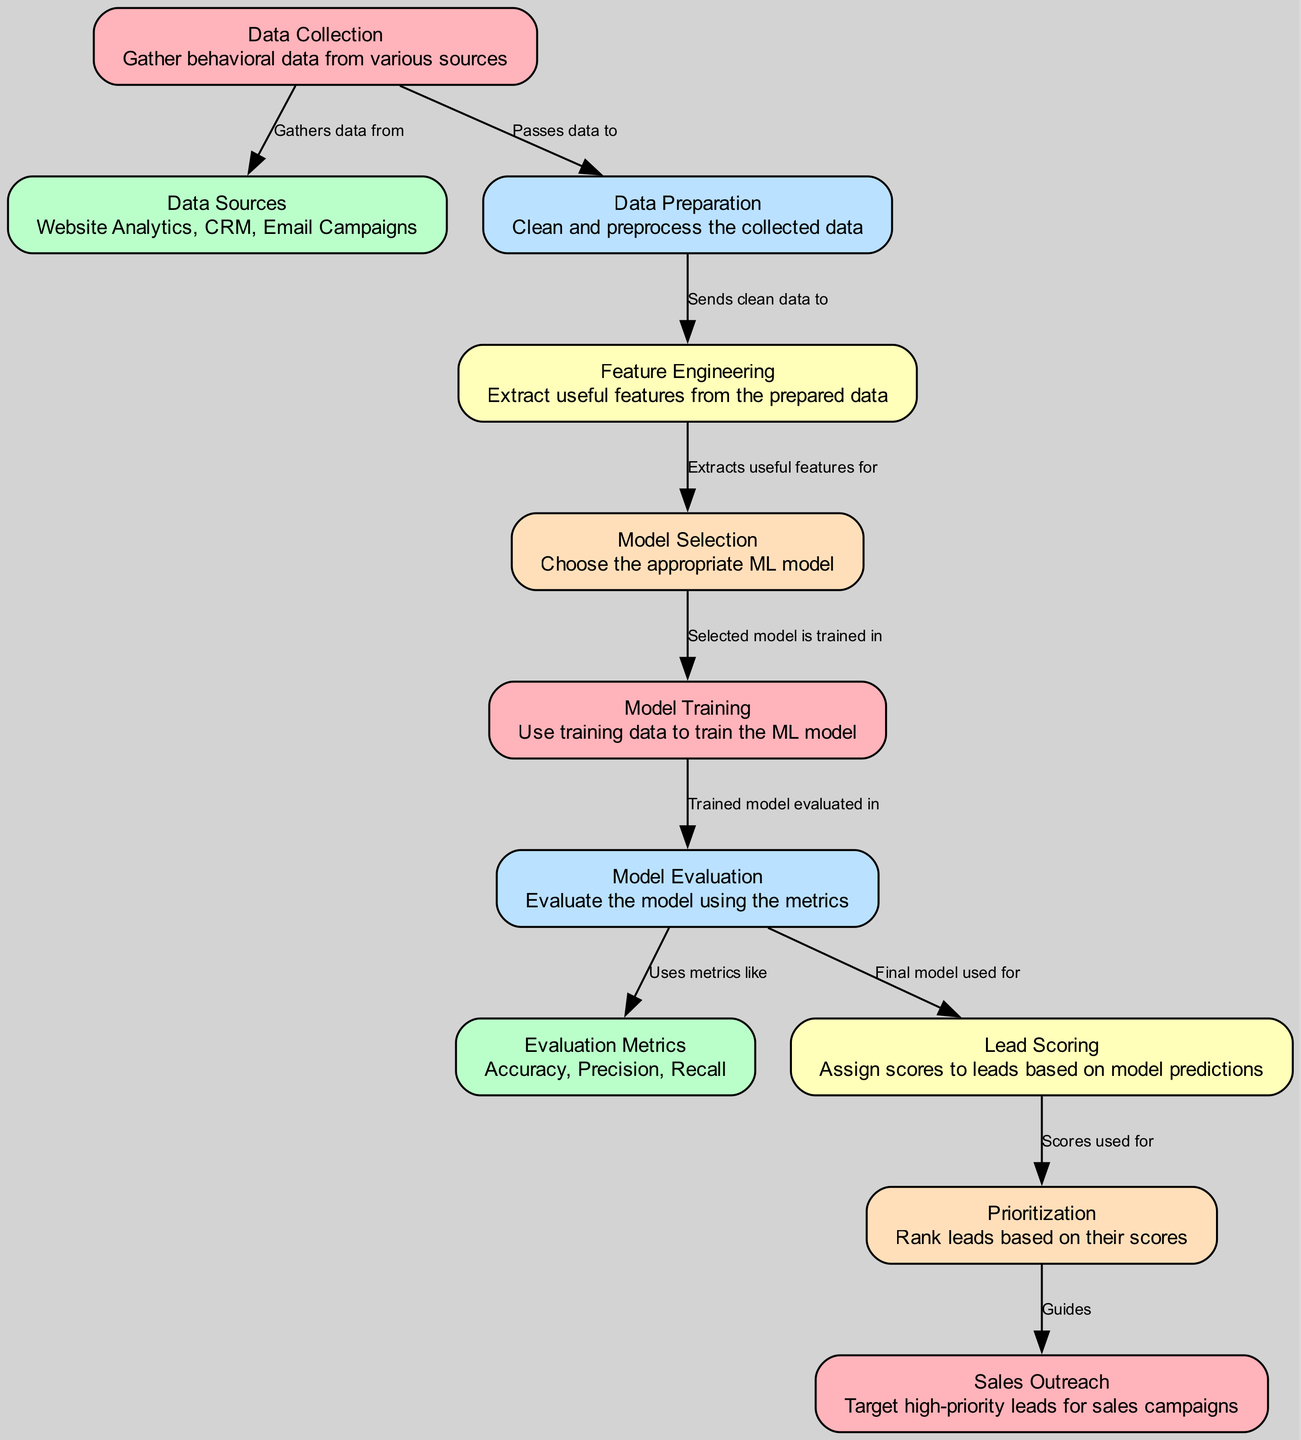What is the first step in the lead scoring model? The diagram shows "Data Collection" as the first node, indicating it is the initial step in the lead scoring process where behavioral data is gathered.
Answer: Data Collection How many data sources are listed in the diagram? The diagram specifies "Website Analytics, CRM, Email Campaigns" as the data sources, which makes a total of three sources.
Answer: Three What does the "Feature Engineering" node do? The "Feature Engineering" node is described as extracting useful features from the prepared data, indicating its role in transforming data into a more usable format for modeling.
Answer: Extracts useful features Which node comes after "Model Selection"? According to the flow in the diagram, "Model Training" is connected directly after "Model Selection," indicating the next phase where the chosen model is trained.
Answer: Model Training What metrics are used for model evaluation? The diagram mentions "Accuracy, Precision, Recall" as the evaluation metrics utilized to gauge the model’s performance after training and before using it for lead scoring.
Answer: Accuracy, Precision, Recall What guides the sales outreach process? The "Prioritization" node is responsible for guiding the sales outreach process by ranking leads based on their assigned scores from the lead scoring model.
Answer: Prioritization What is the role of the "Lead Scoring" node in the diagram? The "Lead Scoring" node leverages the final model to assign scores to leads based on their likelihood to convert, indicating its critical role in prioritizing outreach efforts.
Answer: Assign scores What is the relationship between "Model Evaluation" and "Lead Scoring"? The relationship indicated by a directed edge shows that the model evaluation leads to "Lead Scoring," meaning the evaluated model is directly used to score leads.
Answer: Model Evaluation to Lead Scoring How does the data flow from "Data Preparation" to "Feature Engineering"? The diagram shows that data flows from “Data Preparation” to “Feature Engineering” as the prepared data is sent to extract useful features, showcasing a clear progression from cleaning to feature extraction.
Answer: Sends clean data to 